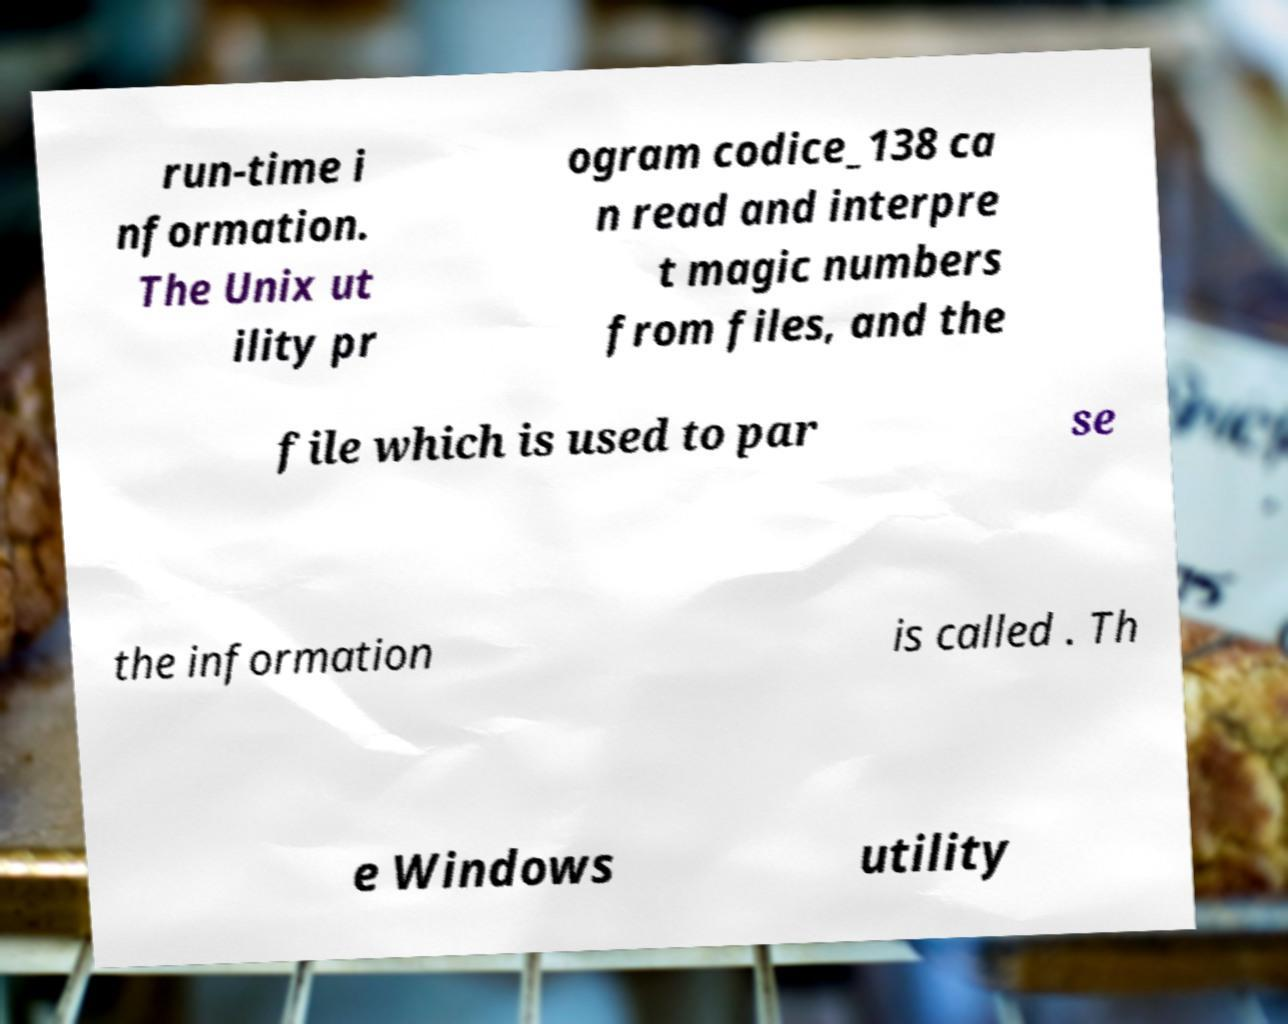Could you assist in decoding the text presented in this image and type it out clearly? run-time i nformation. The Unix ut ility pr ogram codice_138 ca n read and interpre t magic numbers from files, and the file which is used to par se the information is called . Th e Windows utility 